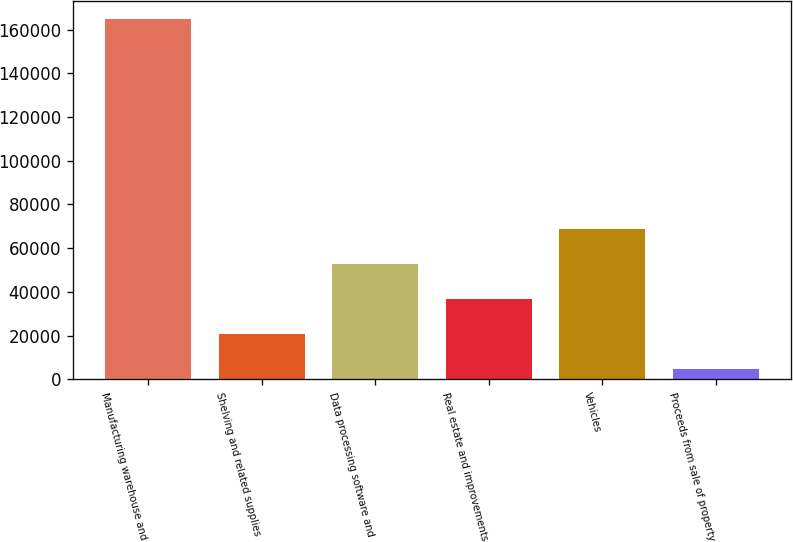<chart> <loc_0><loc_0><loc_500><loc_500><bar_chart><fcel>Manufacturing warehouse and<fcel>Shelving and related supplies<fcel>Data processing software and<fcel>Real estate and improvements<fcel>Vehicles<fcel>Proceeds from sale of property<nl><fcel>164940<fcel>20985<fcel>52975<fcel>36980<fcel>68970<fcel>4990<nl></chart> 